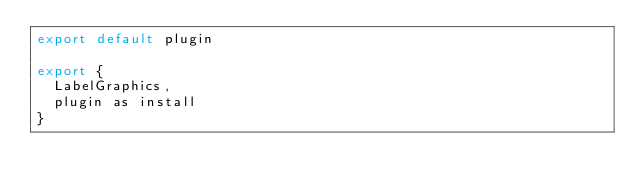Convert code to text. <code><loc_0><loc_0><loc_500><loc_500><_JavaScript_>export default plugin

export {
  LabelGraphics,
  plugin as install
}
</code> 